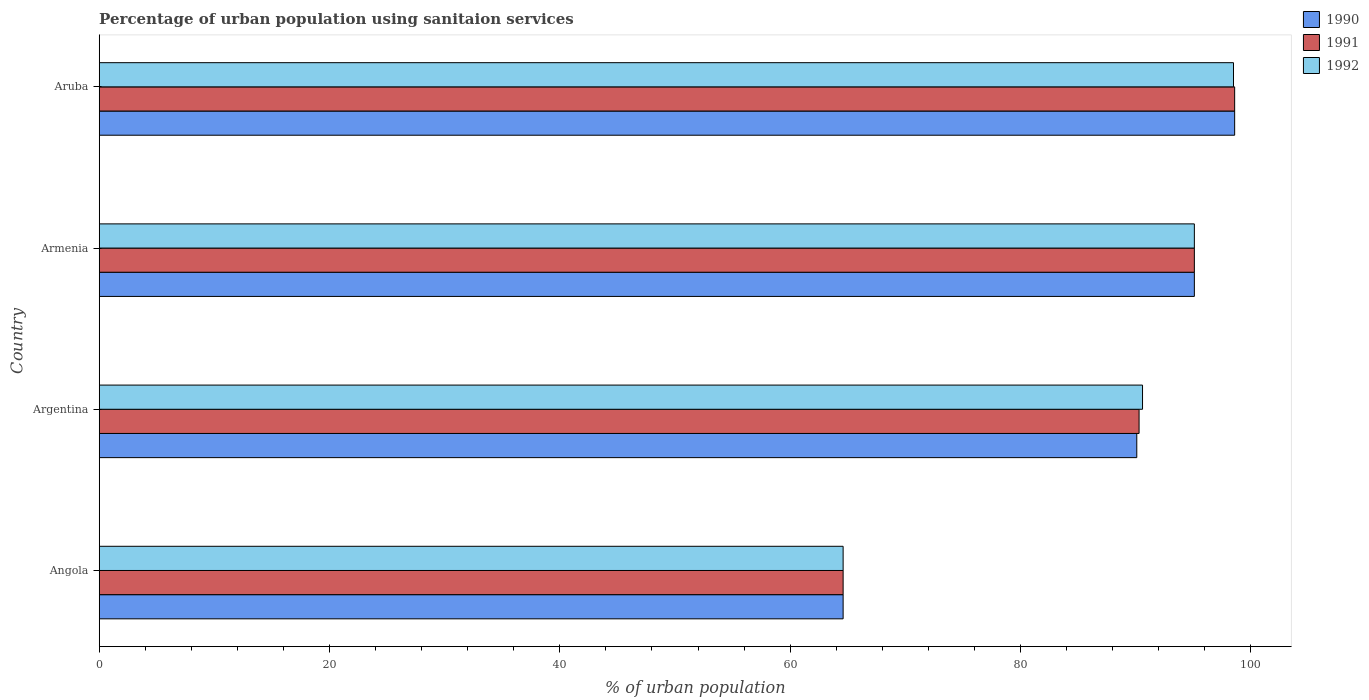How many different coloured bars are there?
Keep it short and to the point. 3. How many groups of bars are there?
Provide a succinct answer. 4. Are the number of bars per tick equal to the number of legend labels?
Your answer should be compact. Yes. How many bars are there on the 3rd tick from the top?
Give a very brief answer. 3. How many bars are there on the 2nd tick from the bottom?
Ensure brevity in your answer.  3. What is the label of the 1st group of bars from the top?
Your answer should be compact. Aruba. What is the percentage of urban population using sanitaion services in 1991 in Angola?
Your answer should be compact. 64.6. Across all countries, what is the maximum percentage of urban population using sanitaion services in 1991?
Your answer should be compact. 98.6. Across all countries, what is the minimum percentage of urban population using sanitaion services in 1990?
Provide a short and direct response. 64.6. In which country was the percentage of urban population using sanitaion services in 1992 maximum?
Offer a very short reply. Aruba. In which country was the percentage of urban population using sanitaion services in 1992 minimum?
Give a very brief answer. Angola. What is the total percentage of urban population using sanitaion services in 1992 in the graph?
Offer a terse response. 348.8. What is the difference between the percentage of urban population using sanitaion services in 1992 in Argentina and that in Armenia?
Offer a terse response. -4.5. What is the difference between the percentage of urban population using sanitaion services in 1990 in Aruba and the percentage of urban population using sanitaion services in 1991 in Armenia?
Offer a terse response. 3.5. What is the average percentage of urban population using sanitaion services in 1991 per country?
Offer a terse response. 87.15. What is the difference between the percentage of urban population using sanitaion services in 1992 and percentage of urban population using sanitaion services in 1991 in Argentina?
Offer a terse response. 0.3. In how many countries, is the percentage of urban population using sanitaion services in 1992 greater than 28 %?
Your answer should be compact. 4. What is the ratio of the percentage of urban population using sanitaion services in 1991 in Angola to that in Armenia?
Ensure brevity in your answer.  0.68. What is the difference between the highest and the second highest percentage of urban population using sanitaion services in 1990?
Provide a short and direct response. 3.5. What is the difference between the highest and the lowest percentage of urban population using sanitaion services in 1992?
Offer a very short reply. 33.9. In how many countries, is the percentage of urban population using sanitaion services in 1991 greater than the average percentage of urban population using sanitaion services in 1991 taken over all countries?
Provide a succinct answer. 3. What does the 1st bar from the top in Aruba represents?
Your response must be concise. 1992. What does the 2nd bar from the bottom in Aruba represents?
Your response must be concise. 1991. How many bars are there?
Offer a terse response. 12. How many countries are there in the graph?
Your response must be concise. 4. Are the values on the major ticks of X-axis written in scientific E-notation?
Provide a short and direct response. No. Does the graph contain any zero values?
Keep it short and to the point. No. Does the graph contain grids?
Keep it short and to the point. No. Where does the legend appear in the graph?
Provide a succinct answer. Top right. How are the legend labels stacked?
Give a very brief answer. Vertical. What is the title of the graph?
Your response must be concise. Percentage of urban population using sanitaion services. What is the label or title of the X-axis?
Your answer should be compact. % of urban population. What is the label or title of the Y-axis?
Your response must be concise. Country. What is the % of urban population of 1990 in Angola?
Ensure brevity in your answer.  64.6. What is the % of urban population in 1991 in Angola?
Keep it short and to the point. 64.6. What is the % of urban population of 1992 in Angola?
Your response must be concise. 64.6. What is the % of urban population of 1990 in Argentina?
Provide a succinct answer. 90.1. What is the % of urban population of 1991 in Argentina?
Your answer should be compact. 90.3. What is the % of urban population of 1992 in Argentina?
Your answer should be compact. 90.6. What is the % of urban population in 1990 in Armenia?
Provide a succinct answer. 95.1. What is the % of urban population in 1991 in Armenia?
Your answer should be very brief. 95.1. What is the % of urban population in 1992 in Armenia?
Ensure brevity in your answer.  95.1. What is the % of urban population in 1990 in Aruba?
Ensure brevity in your answer.  98.6. What is the % of urban population of 1991 in Aruba?
Your answer should be compact. 98.6. What is the % of urban population of 1992 in Aruba?
Provide a succinct answer. 98.5. Across all countries, what is the maximum % of urban population of 1990?
Your response must be concise. 98.6. Across all countries, what is the maximum % of urban population in 1991?
Offer a terse response. 98.6. Across all countries, what is the maximum % of urban population in 1992?
Offer a terse response. 98.5. Across all countries, what is the minimum % of urban population of 1990?
Ensure brevity in your answer.  64.6. Across all countries, what is the minimum % of urban population in 1991?
Your answer should be very brief. 64.6. Across all countries, what is the minimum % of urban population of 1992?
Provide a short and direct response. 64.6. What is the total % of urban population of 1990 in the graph?
Make the answer very short. 348.4. What is the total % of urban population of 1991 in the graph?
Offer a terse response. 348.6. What is the total % of urban population of 1992 in the graph?
Ensure brevity in your answer.  348.8. What is the difference between the % of urban population in 1990 in Angola and that in Argentina?
Provide a succinct answer. -25.5. What is the difference between the % of urban population in 1991 in Angola and that in Argentina?
Ensure brevity in your answer.  -25.7. What is the difference between the % of urban population of 1992 in Angola and that in Argentina?
Make the answer very short. -26. What is the difference between the % of urban population in 1990 in Angola and that in Armenia?
Provide a short and direct response. -30.5. What is the difference between the % of urban population of 1991 in Angola and that in Armenia?
Give a very brief answer. -30.5. What is the difference between the % of urban population of 1992 in Angola and that in Armenia?
Make the answer very short. -30.5. What is the difference between the % of urban population of 1990 in Angola and that in Aruba?
Provide a short and direct response. -34. What is the difference between the % of urban population in 1991 in Angola and that in Aruba?
Give a very brief answer. -34. What is the difference between the % of urban population in 1992 in Angola and that in Aruba?
Your answer should be very brief. -33.9. What is the difference between the % of urban population of 1991 in Argentina and that in Armenia?
Provide a short and direct response. -4.8. What is the difference between the % of urban population in 1992 in Argentina and that in Armenia?
Your response must be concise. -4.5. What is the difference between the % of urban population of 1990 in Argentina and that in Aruba?
Give a very brief answer. -8.5. What is the difference between the % of urban population in 1990 in Armenia and that in Aruba?
Your answer should be very brief. -3.5. What is the difference between the % of urban population of 1991 in Armenia and that in Aruba?
Make the answer very short. -3.5. What is the difference between the % of urban population in 1990 in Angola and the % of urban population in 1991 in Argentina?
Keep it short and to the point. -25.7. What is the difference between the % of urban population in 1990 in Angola and the % of urban population in 1991 in Armenia?
Keep it short and to the point. -30.5. What is the difference between the % of urban population of 1990 in Angola and the % of urban population of 1992 in Armenia?
Your answer should be compact. -30.5. What is the difference between the % of urban population of 1991 in Angola and the % of urban population of 1992 in Armenia?
Provide a succinct answer. -30.5. What is the difference between the % of urban population in 1990 in Angola and the % of urban population in 1991 in Aruba?
Give a very brief answer. -34. What is the difference between the % of urban population of 1990 in Angola and the % of urban population of 1992 in Aruba?
Give a very brief answer. -33.9. What is the difference between the % of urban population of 1991 in Angola and the % of urban population of 1992 in Aruba?
Give a very brief answer. -33.9. What is the difference between the % of urban population of 1991 in Argentina and the % of urban population of 1992 in Armenia?
Keep it short and to the point. -4.8. What is the difference between the % of urban population in 1990 in Argentina and the % of urban population in 1991 in Aruba?
Provide a succinct answer. -8.5. What is the average % of urban population of 1990 per country?
Keep it short and to the point. 87.1. What is the average % of urban population of 1991 per country?
Your answer should be very brief. 87.15. What is the average % of urban population of 1992 per country?
Offer a terse response. 87.2. What is the difference between the % of urban population in 1990 and % of urban population in 1992 in Angola?
Offer a very short reply. 0. What is the difference between the % of urban population of 1990 and % of urban population of 1992 in Argentina?
Give a very brief answer. -0.5. What is the difference between the % of urban population in 1991 and % of urban population in 1992 in Argentina?
Your answer should be very brief. -0.3. What is the difference between the % of urban population of 1990 and % of urban population of 1991 in Armenia?
Your response must be concise. 0. What is the difference between the % of urban population of 1991 and % of urban population of 1992 in Armenia?
Provide a short and direct response. 0. What is the difference between the % of urban population in 1991 and % of urban population in 1992 in Aruba?
Make the answer very short. 0.1. What is the ratio of the % of urban population in 1990 in Angola to that in Argentina?
Provide a succinct answer. 0.72. What is the ratio of the % of urban population in 1991 in Angola to that in Argentina?
Keep it short and to the point. 0.72. What is the ratio of the % of urban population in 1992 in Angola to that in Argentina?
Ensure brevity in your answer.  0.71. What is the ratio of the % of urban population in 1990 in Angola to that in Armenia?
Ensure brevity in your answer.  0.68. What is the ratio of the % of urban population of 1991 in Angola to that in Armenia?
Provide a succinct answer. 0.68. What is the ratio of the % of urban population of 1992 in Angola to that in Armenia?
Provide a succinct answer. 0.68. What is the ratio of the % of urban population of 1990 in Angola to that in Aruba?
Your answer should be compact. 0.66. What is the ratio of the % of urban population of 1991 in Angola to that in Aruba?
Provide a short and direct response. 0.66. What is the ratio of the % of urban population in 1992 in Angola to that in Aruba?
Your answer should be compact. 0.66. What is the ratio of the % of urban population of 1990 in Argentina to that in Armenia?
Ensure brevity in your answer.  0.95. What is the ratio of the % of urban population in 1991 in Argentina to that in Armenia?
Your answer should be very brief. 0.95. What is the ratio of the % of urban population of 1992 in Argentina to that in Armenia?
Offer a terse response. 0.95. What is the ratio of the % of urban population of 1990 in Argentina to that in Aruba?
Your response must be concise. 0.91. What is the ratio of the % of urban population in 1991 in Argentina to that in Aruba?
Offer a terse response. 0.92. What is the ratio of the % of urban population in 1992 in Argentina to that in Aruba?
Offer a very short reply. 0.92. What is the ratio of the % of urban population in 1990 in Armenia to that in Aruba?
Provide a short and direct response. 0.96. What is the ratio of the % of urban population in 1991 in Armenia to that in Aruba?
Your answer should be very brief. 0.96. What is the ratio of the % of urban population of 1992 in Armenia to that in Aruba?
Offer a terse response. 0.97. What is the difference between the highest and the second highest % of urban population in 1991?
Your answer should be very brief. 3.5. What is the difference between the highest and the second highest % of urban population in 1992?
Your answer should be very brief. 3.4. What is the difference between the highest and the lowest % of urban population of 1990?
Your response must be concise. 34. What is the difference between the highest and the lowest % of urban population in 1991?
Provide a short and direct response. 34. What is the difference between the highest and the lowest % of urban population of 1992?
Provide a short and direct response. 33.9. 